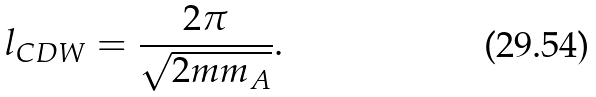Convert formula to latex. <formula><loc_0><loc_0><loc_500><loc_500>l _ { C D W } = \frac { 2 \pi } { \sqrt { 2 m m _ { A } } } .</formula> 